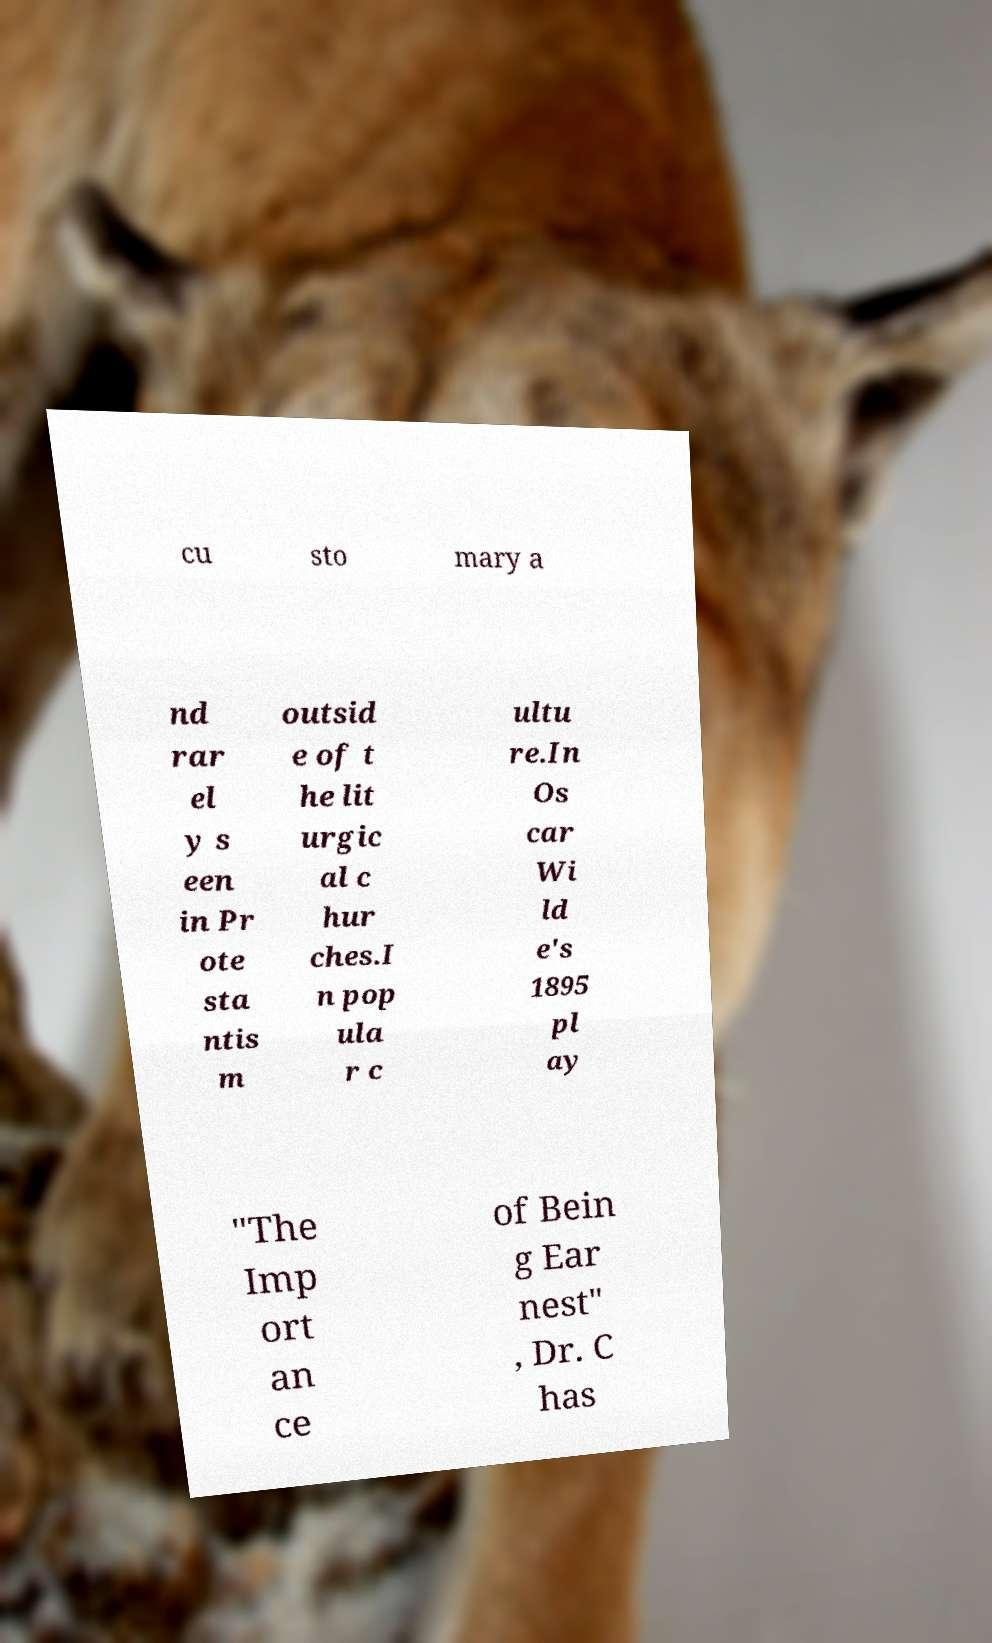Could you extract and type out the text from this image? cu sto mary a nd rar el y s een in Pr ote sta ntis m outsid e of t he lit urgic al c hur ches.I n pop ula r c ultu re.In Os car Wi ld e's 1895 pl ay "The Imp ort an ce of Bein g Ear nest" , Dr. C has 